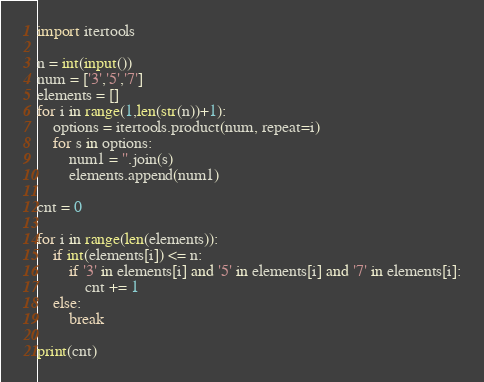<code> <loc_0><loc_0><loc_500><loc_500><_Python_>import itertools

n = int(input())
num = ['3','5','7']
elements = []
for i in range(1,len(str(n))+1):
    options = itertools.product(num, repeat=i)
    for s in options:
        num1 = ''.join(s)
        elements.append(num1)

cnt = 0

for i in range(len(elements)):
    if int(elements[i]) <= n:
        if '3' in elements[i] and '5' in elements[i] and '7' in elements[i]:
            cnt += 1
    else:
        break

print(cnt)</code> 